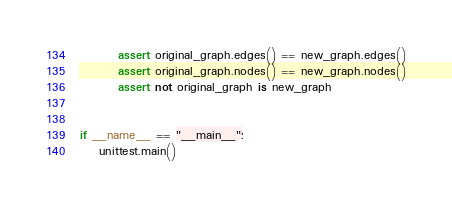<code> <loc_0><loc_0><loc_500><loc_500><_Python_>
        assert original_graph.edges() == new_graph.edges()
        assert original_graph.nodes() == new_graph.nodes()
        assert not original_graph is new_graph


if __name__ == "__main__":
    unittest.main()
</code> 